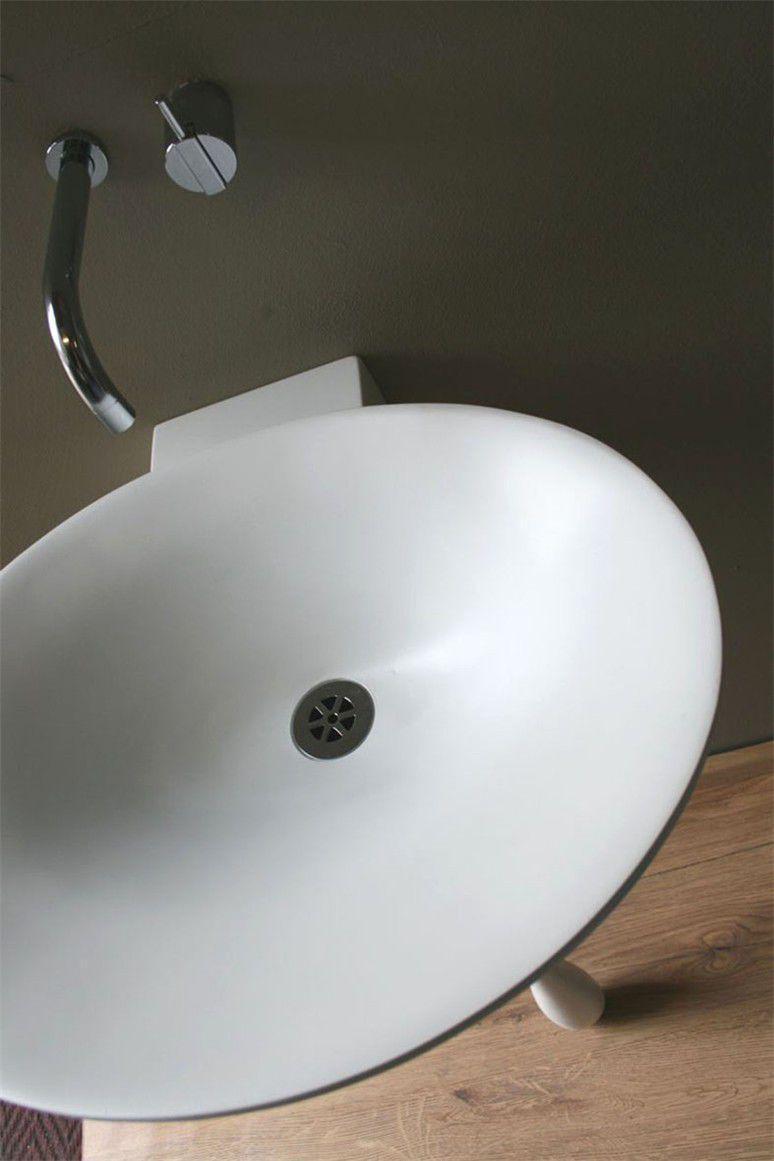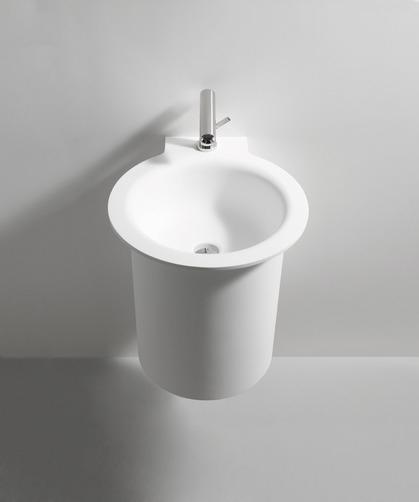The first image is the image on the left, the second image is the image on the right. For the images shown, is this caption "Each sink is rounded, white, sits atop a counter, and has the spout and faucet mounted on the wall above it." true? Answer yes or no. No. The first image is the image on the left, the second image is the image on the right. Evaluate the accuracy of this statement regarding the images: "One white sink is round and one is oval, neither directly attached to a chrome spout fixture that overhangs it.". Is it true? Answer yes or no. No. 